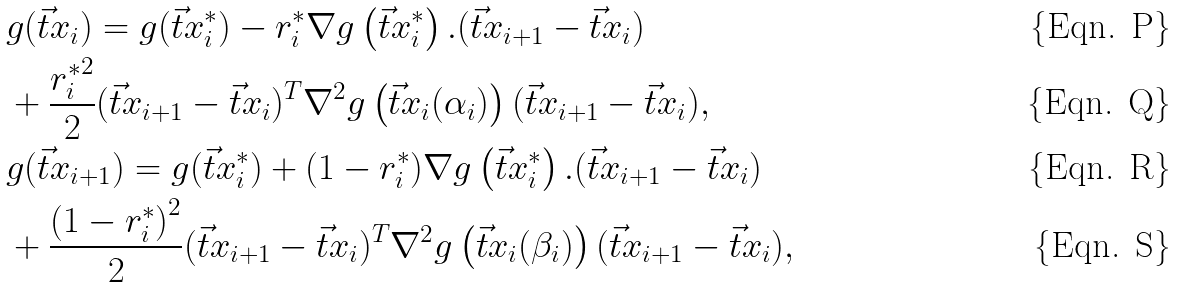Convert formula to latex. <formula><loc_0><loc_0><loc_500><loc_500>& g ( \vec { t } { x } _ { i } ) = g ( \vec { t } { x } _ { i } ^ { * } ) - r ^ { * } _ { i } \nabla g \left ( \vec { t } { x } ^ { * } _ { i } \right ) . ( \vec { t } { x } _ { i + 1 } - \vec { t } { x } _ { i } ) \\ & + \frac { { r ^ { * } _ { i } } ^ { 2 } } { 2 } ( \vec { t } { x } _ { i + 1 } - \vec { t } { x } _ { i } ) ^ { T } \nabla ^ { 2 } g \left ( \vec { t } { x } _ { i } ( \alpha _ { i } ) \right ) ( \vec { t } { x } _ { i + 1 } - \vec { t } { x } _ { i } ) , \\ & g ( \vec { t } { x } _ { i + 1 } ) = g ( \vec { t } { x } _ { i } ^ { * } ) + ( 1 - r ^ { * } _ { i } ) \nabla g \left ( \vec { t } { x } ^ { * } _ { i } \right ) . ( \vec { t } { x } _ { i + 1 } - \vec { t } { x } _ { i } ) \\ & + \frac { { ( 1 - r ^ { * } _ { i } ) } ^ { 2 } } { 2 } ( \vec { t } { x } _ { i + 1 } - \vec { t } { x } _ { i } ) ^ { T } \nabla ^ { 2 } g \left ( \vec { t } { x } _ { i } ( \beta _ { i } ) \right ) ( \vec { t } { x } _ { i + 1 } - \vec { t } { x } _ { i } ) ,</formula> 